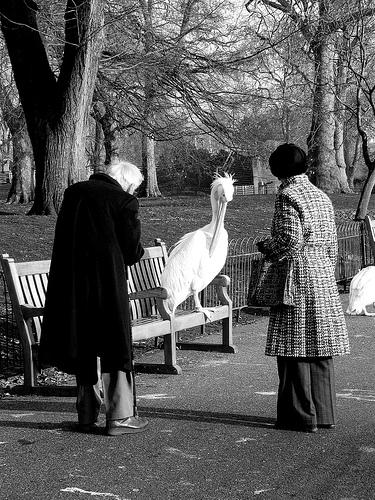Enumerate the subjects and background elements in the image. Subjects: man, woman, bird, wooden bench. Background elements: large tree, stairs, iron gate, park setting. Describe only what the woman is doing/holding in the image. The woman is wearing a patterned coat and a black hat, and holding a large black-and-white purse. Write a description of the main subjects in the image and the setting. A white-haired man wearing a long black coat, a woman in a black hat and long coat with a handbag, and a large white bird on a bench, are situated in a park with stairs, a tree, and an iron gate. Provide a concise description of the overall scene depicted in the image. An elderly man, a woman in a hat, and a large white bird on a wooden bench, are observed by two people wearing long coats. Mention a unique or unexpected aspect of the image. Interestingly, there is a piece of white bird poop lying on the ground in the image. Mention the key scene elements, including people, animal, and their interaction. An elderly man and woman wearing long outerwear watch a large bird standing on a park bench, with a tree and stairs nearby. Briefly describe the wooden bench in the image. The large wooden bench has three armrests and is the resting place for the large bird. Describe a specific detail about the bird in the image. The white bird has a very long beak and is standing on a bench with its back end facing the ground. Describe the main subjects' appearance and their focus in the image. An old man with white hair in a long black coat and a woman in a patterned coat with a black hat are watching a large white bird on a bench. Share what the man in the image is doing and a specific feature about him. The white-haired elderly man is observing the bird with the woman while wearing a long black coat. 